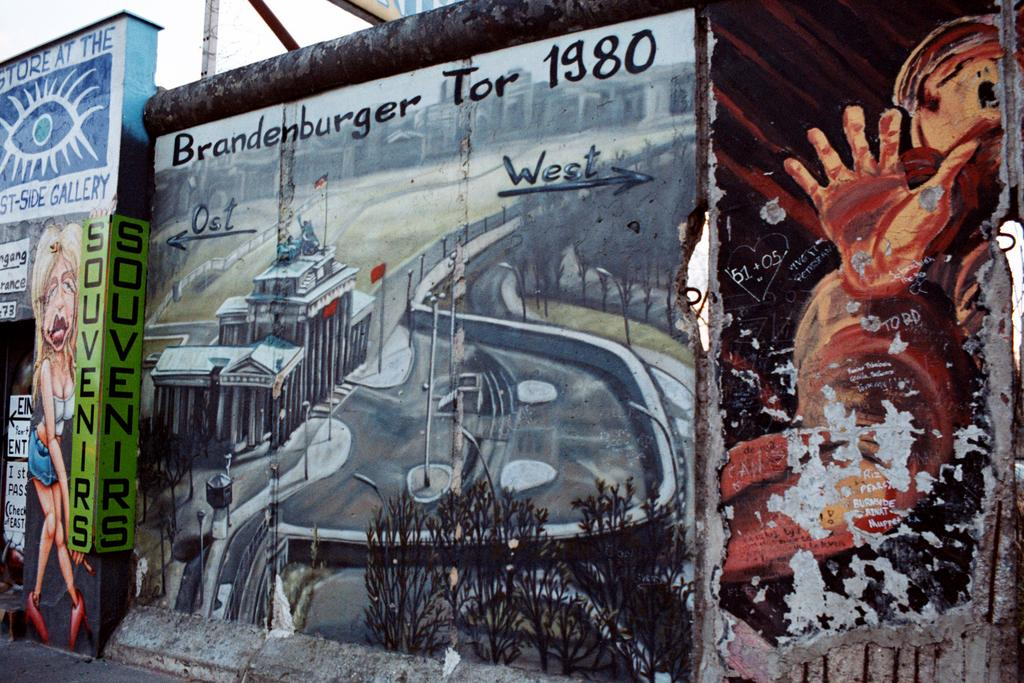What can be seen on the wall in the image? There are paintings and text on the wall in the image. What else is present on the wall besides the paintings? There is a board with text on the wall in the image. What other object can be seen in the image? There is a pole in the image. What is visible in the background of the image? The sky is visible in the image. What type of rod is being used by the creator of the paintings in the image? There is no rod or creator of the paintings present in the image. 